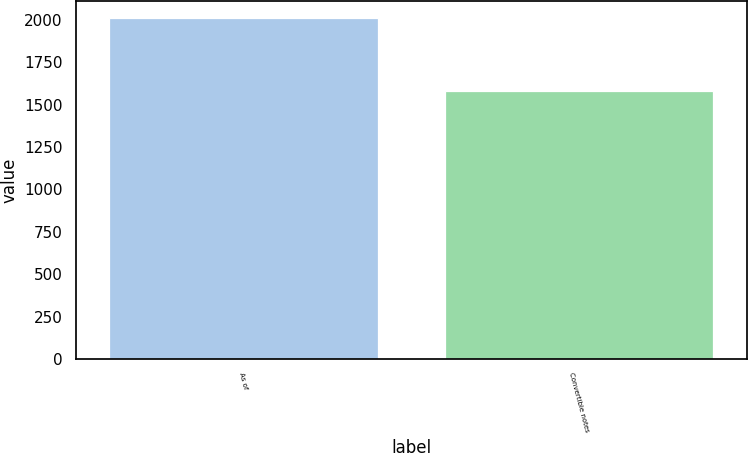<chart> <loc_0><loc_0><loc_500><loc_500><bar_chart><fcel>As of<fcel>Convertible notes<nl><fcel>2011<fcel>1578<nl></chart> 